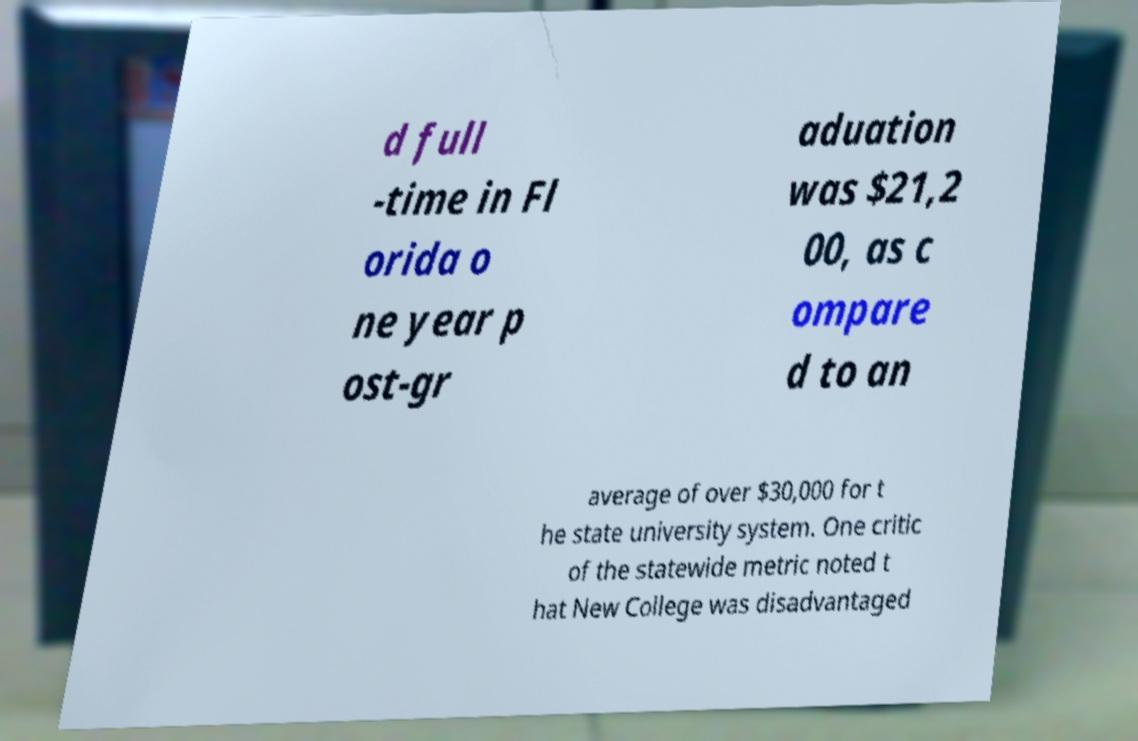For documentation purposes, I need the text within this image transcribed. Could you provide that? d full -time in Fl orida o ne year p ost-gr aduation was $21,2 00, as c ompare d to an average of over $30,000 for t he state university system. One critic of the statewide metric noted t hat New College was disadvantaged 